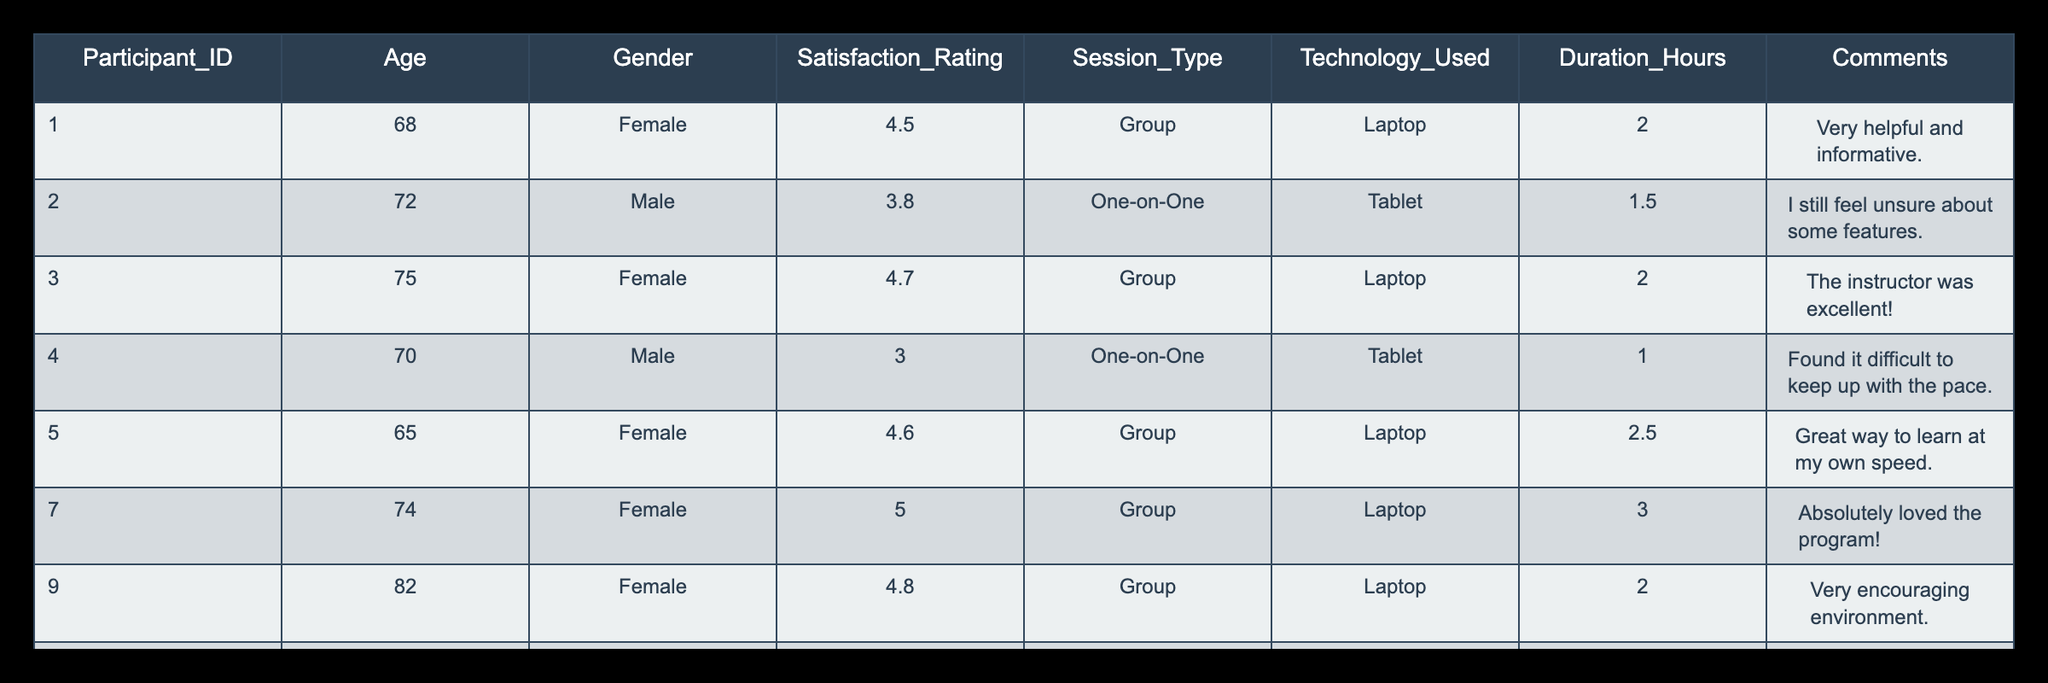What is the satisfaction rating of the participant with ID 1? By looking at the table, I can directly find the Satisfaction_Rating for Participant_ID 1, which is listed as 4.5.
Answer: 4.5 What percentage of participants had a satisfaction rating higher than 4.0? There are 6 participants, and 5 of them have a satisfaction rating higher than 4.0 (4.5, 4.7, 4.6, 5.0, 4.8). The percentage is calculated as (5/8) * 100 = 62.5%.
Answer: 62.5% Is the satisfaction rating of participants who used laptops generally higher than those who used tablets? Participants who used laptops have ratings of 4.5, 4.7, 4.6, 5.0, and 4.8, which averages to 4.72. For tablets, ratings are 3.8 and 2.5, averaging 3.15. Since 4.72 > 3.15, the statement is true.
Answer: Yes What is the average satisfaction rating for one-on-one sessions? The satisfaction ratings for one-on-one sessions are 3.8 and 2.5. The average is calculated as (3.8 + 2.5) / 2 = 3.15.
Answer: 3.15 Which participant provided a comment indicating they found it "difficult to keep up"? By scanning through the comments, Participant_ID 4's comment states, "Found it difficult to keep up with the pace." Therefore, the answer is Participant_ID 4.
Answer: Participant_ID 4 What is the highest satisfaction rating reported in the table, and which session type does it correspond to? The highest satisfaction rating is 5.0, which corresponds to a Group session, as seen in the row for Participant_ID 7.
Answer: 5.0, Group How many participants were female, and what was their average satisfaction rating? There are 5 female participants (IDs 1, 3, 5, 7, 9). Their ratings are 4.5, 4.7, 4.6, 5.0, and 4.8. Calculating the average (4.5 + 4.7 + 4.6 + 5.0 + 4.8) / 5 = 4.64.
Answer: 5, 4.64 Did any participant express feeling unsure about the features after the training? Based on the comments, Participant_ID 2 specifically stated, "I still feel unsure about some features." This confirms that someone did express uncertainty.
Answer: Yes 